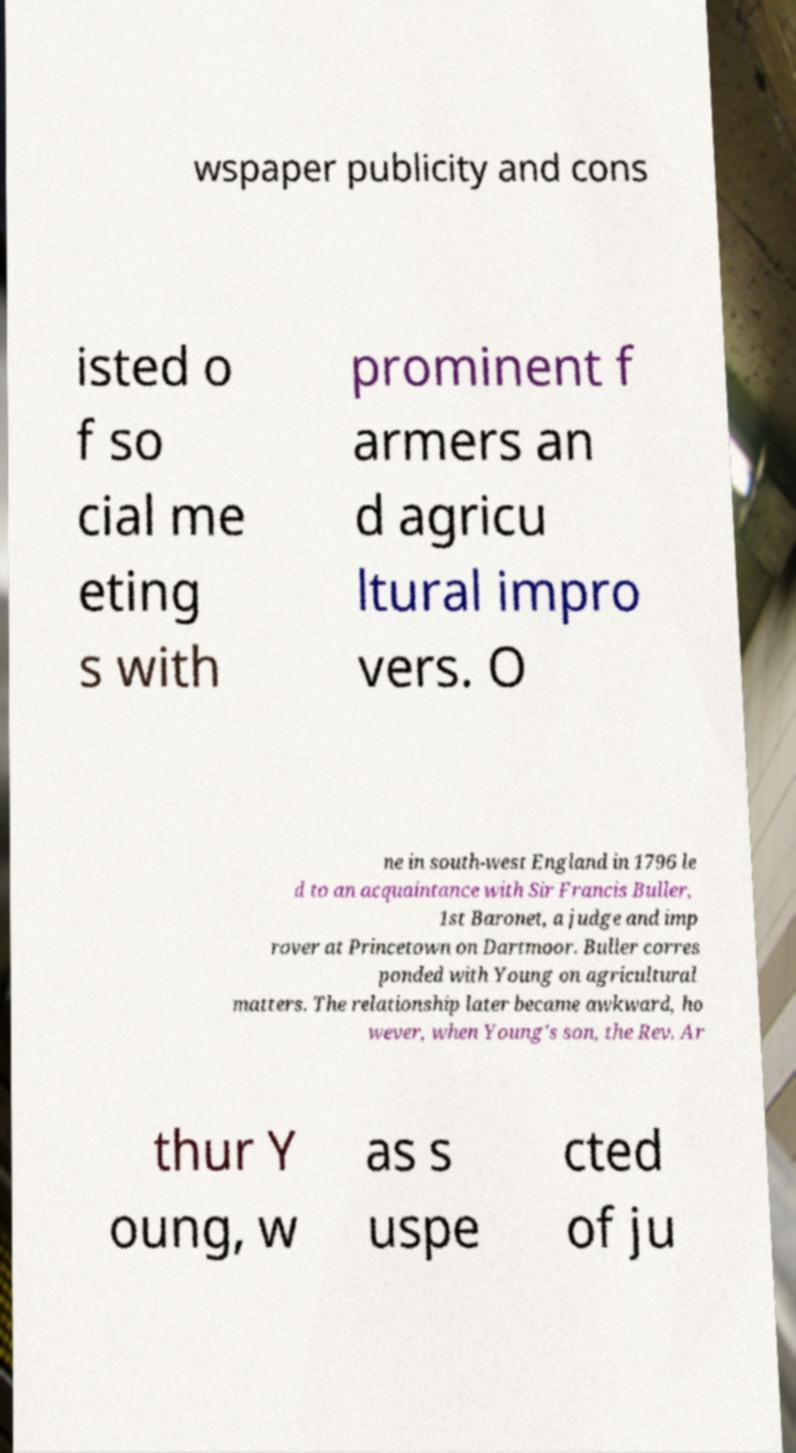What messages or text are displayed in this image? I need them in a readable, typed format. wspaper publicity and cons isted o f so cial me eting s with prominent f armers an d agricu ltural impro vers. O ne in south-west England in 1796 le d to an acquaintance with Sir Francis Buller, 1st Baronet, a judge and imp rover at Princetown on Dartmoor. Buller corres ponded with Young on agricultural matters. The relationship later became awkward, ho wever, when Young's son, the Rev. Ar thur Y oung, w as s uspe cted of ju 